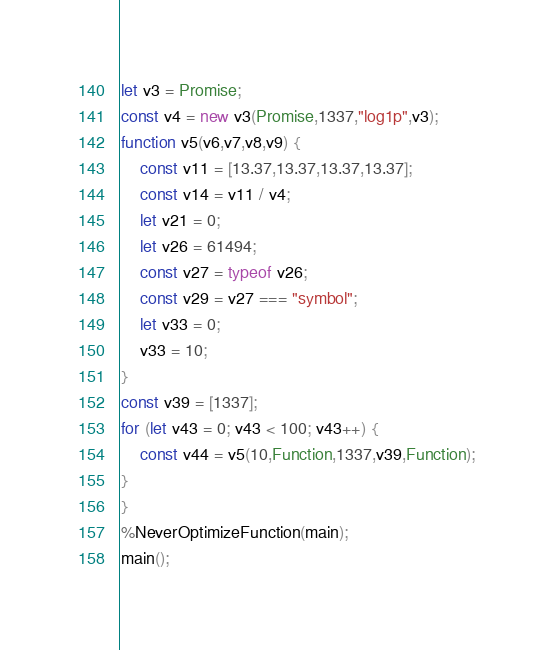Convert code to text. <code><loc_0><loc_0><loc_500><loc_500><_JavaScript_>let v3 = Promise;
const v4 = new v3(Promise,1337,"log1p",v3);
function v5(v6,v7,v8,v9) {
    const v11 = [13.37,13.37,13.37,13.37];
    const v14 = v11 / v4;
    let v21 = 0;
    let v26 = 61494;
    const v27 = typeof v26;
    const v29 = v27 === "symbol";
    let v33 = 0;
    v33 = 10;
}
const v39 = [1337];
for (let v43 = 0; v43 < 100; v43++) {
    const v44 = v5(10,Function,1337,v39,Function);
}
}
%NeverOptimizeFunction(main);
main();
</code> 